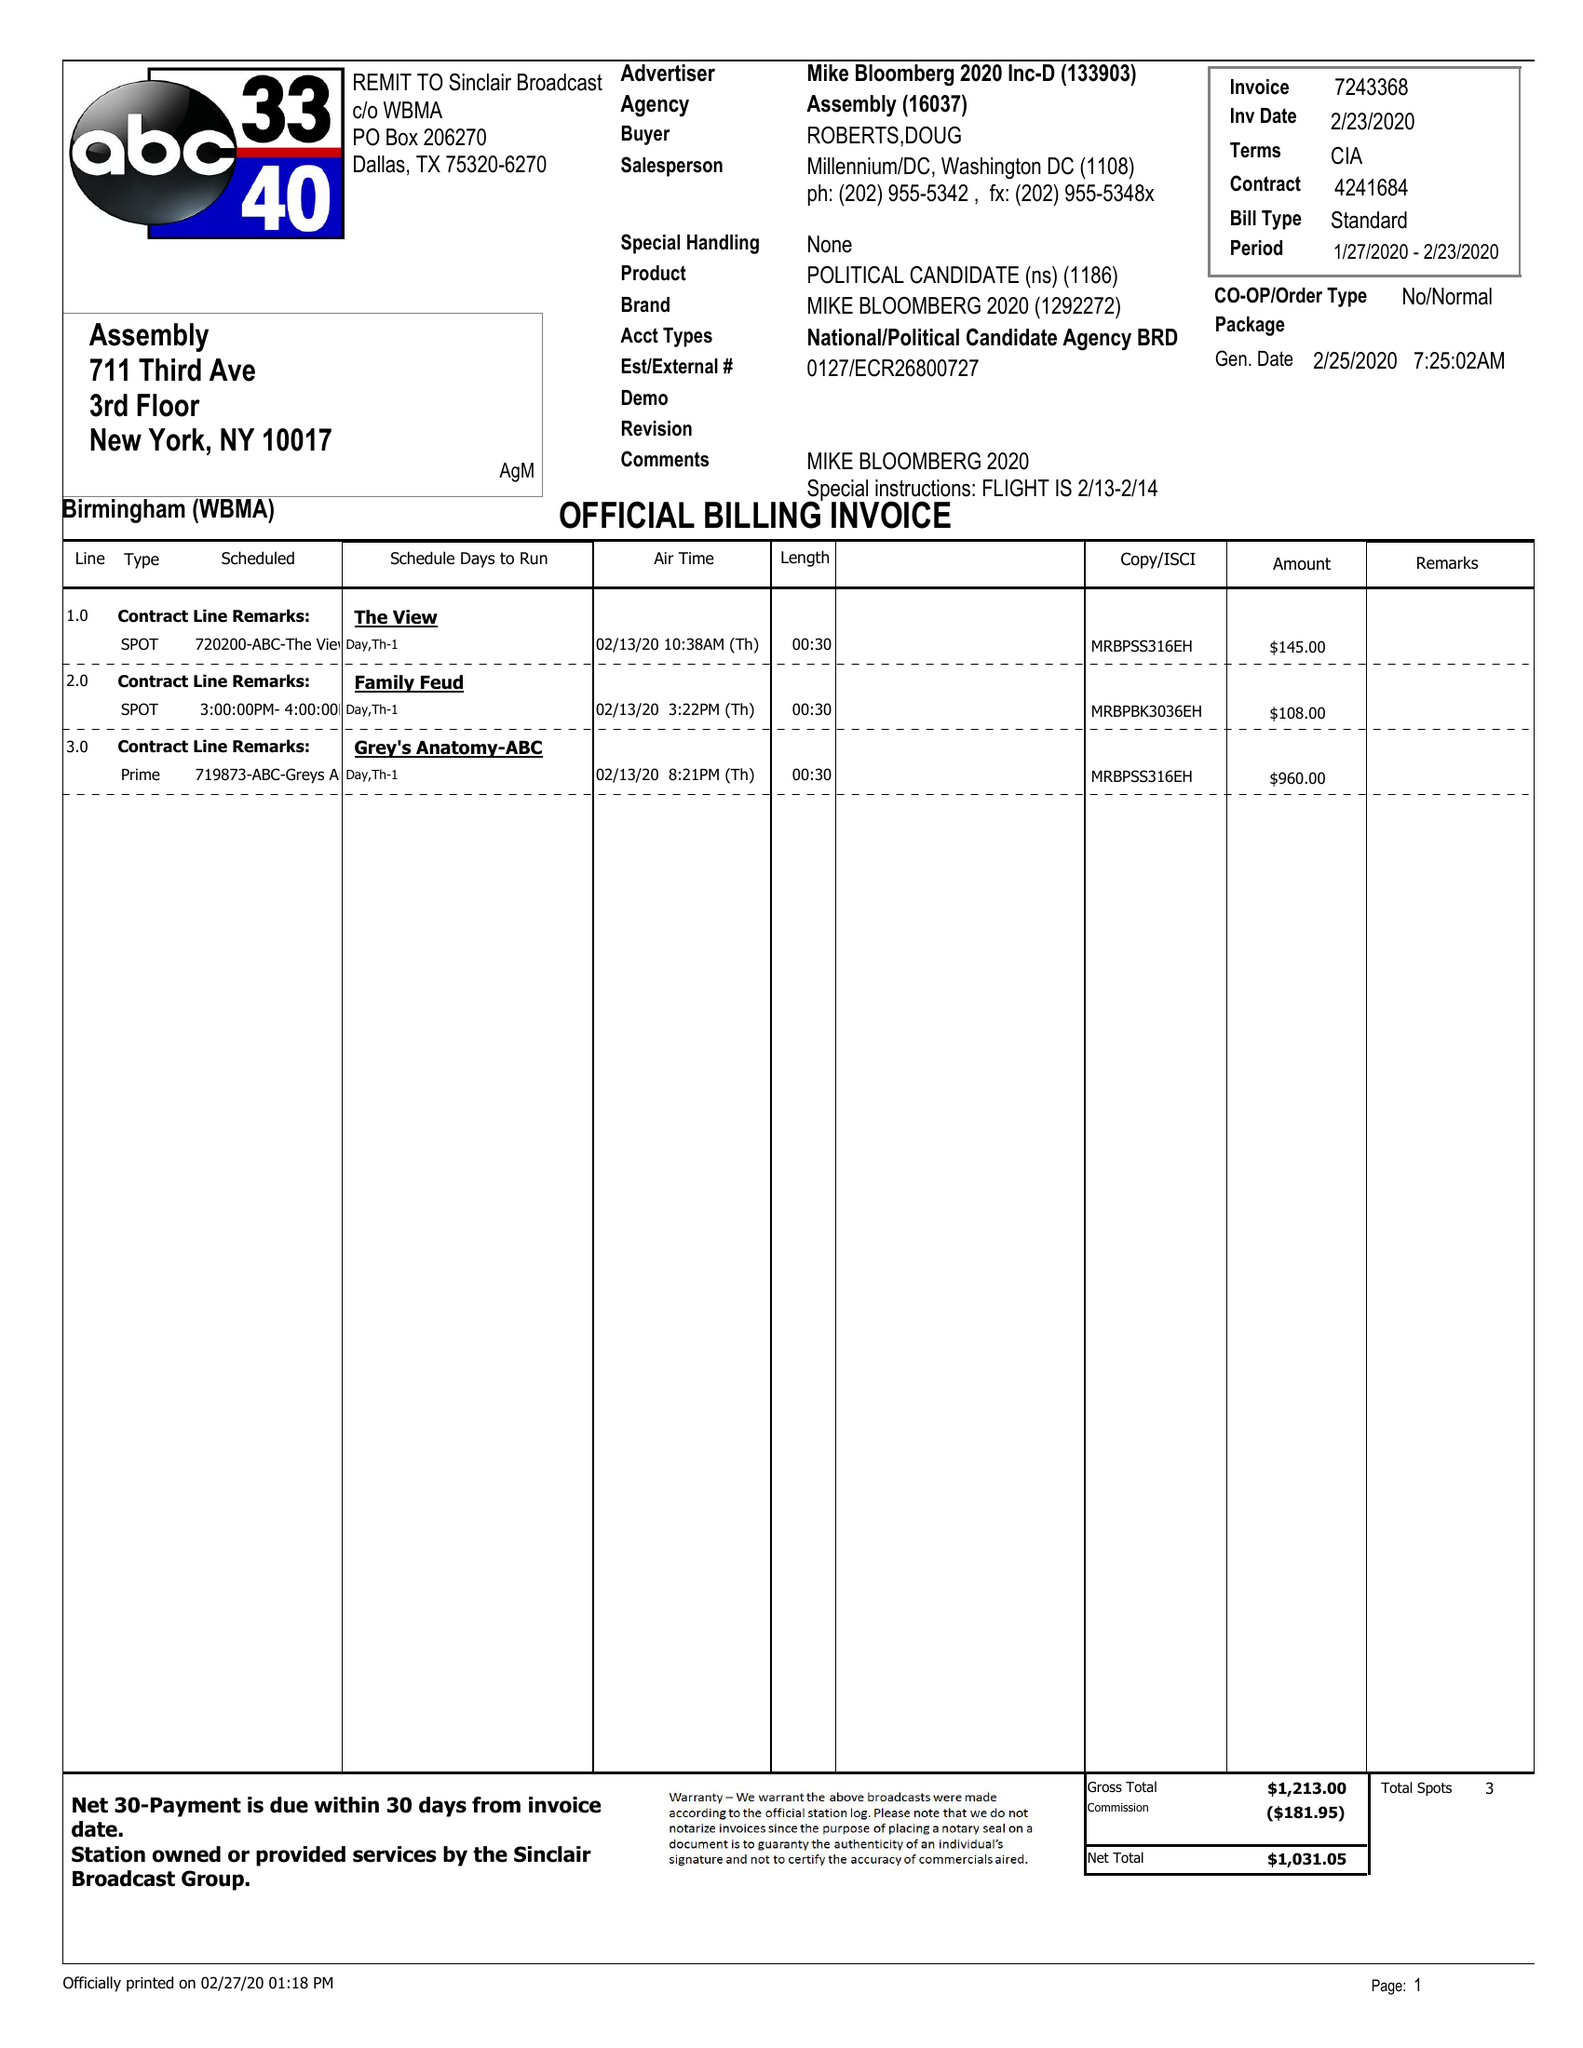What is the value for the contract_num?
Answer the question using a single word or phrase. 4241684 